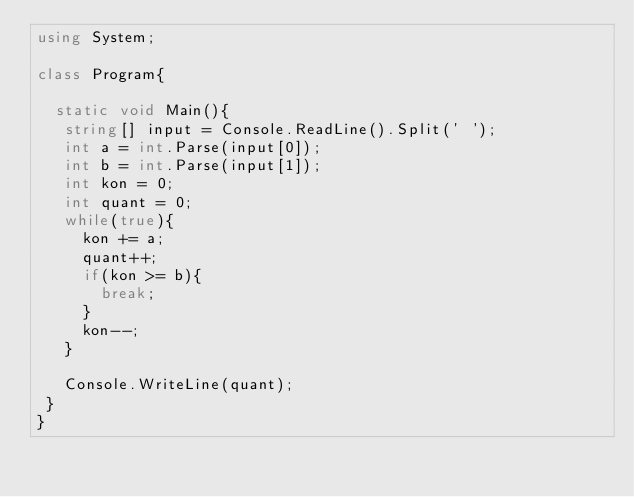Convert code to text. <code><loc_0><loc_0><loc_500><loc_500><_C#_>using System;

class Program{
  
  static void Main(){
   string[] input = Console.ReadLine().Split(' ');
   int a = int.Parse(input[0]);
   int b = int.Parse(input[1]); 
   int kon = 0;
   int quant = 0;
   while(true){
     kon += a;
     quant++;
     if(kon >= b){
       break; 
     }
     kon--;
   }

   Console.WriteLine(quant);
 }
}</code> 